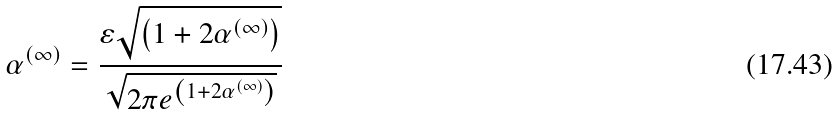Convert formula to latex. <formula><loc_0><loc_0><loc_500><loc_500>\alpha ^ { \left ( \infty \right ) } = \frac { \varepsilon \sqrt { \left ( 1 + 2 \alpha ^ { \left ( \infty \right ) } \right ) } } { \sqrt { 2 \pi e ^ { \left ( 1 + 2 \alpha ^ { \left ( \infty \right ) } \right ) } } }</formula> 